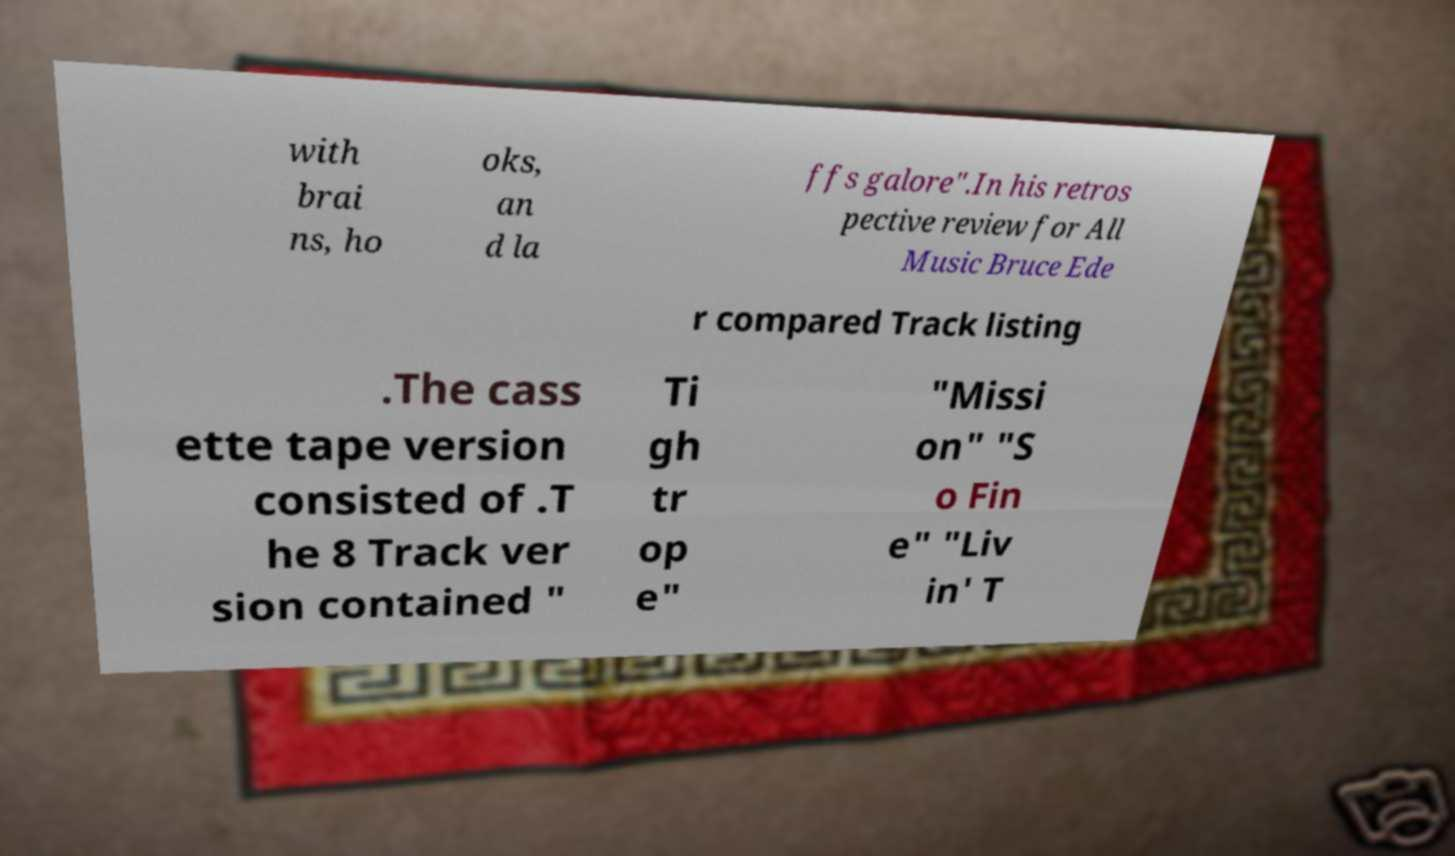Could you extract and type out the text from this image? with brai ns, ho oks, an d la ffs galore".In his retros pective review for All Music Bruce Ede r compared Track listing .The cass ette tape version consisted of .T he 8 Track ver sion contained " Ti gh tr op e" "Missi on" "S o Fin e" "Liv in' T 